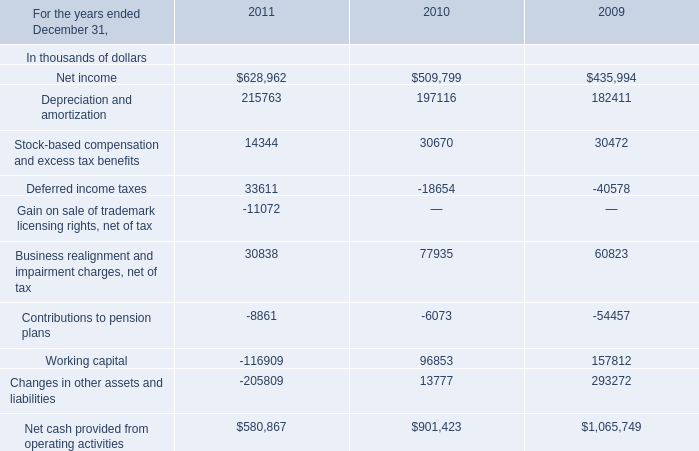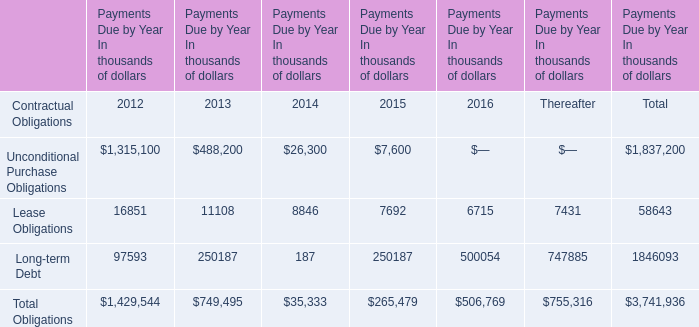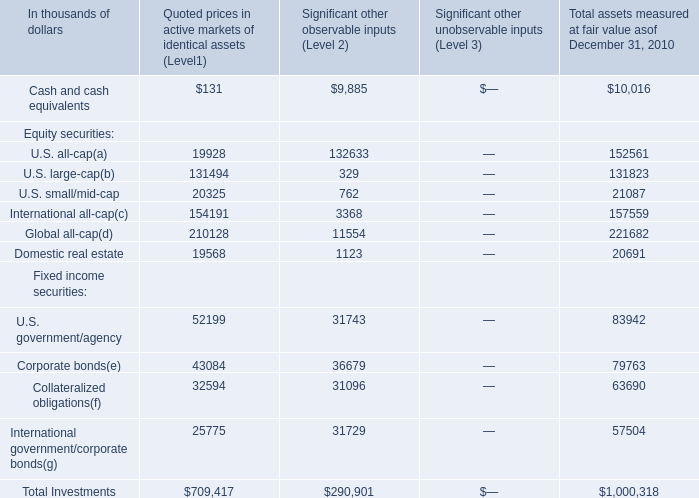What is the sum of Fixed income securities in Total assets measured at fair value as of December 31, 2010 ? (in thousand) 
Computations: (((83942 + 79763) + 63690) + 57504)
Answer: 284899.0. 